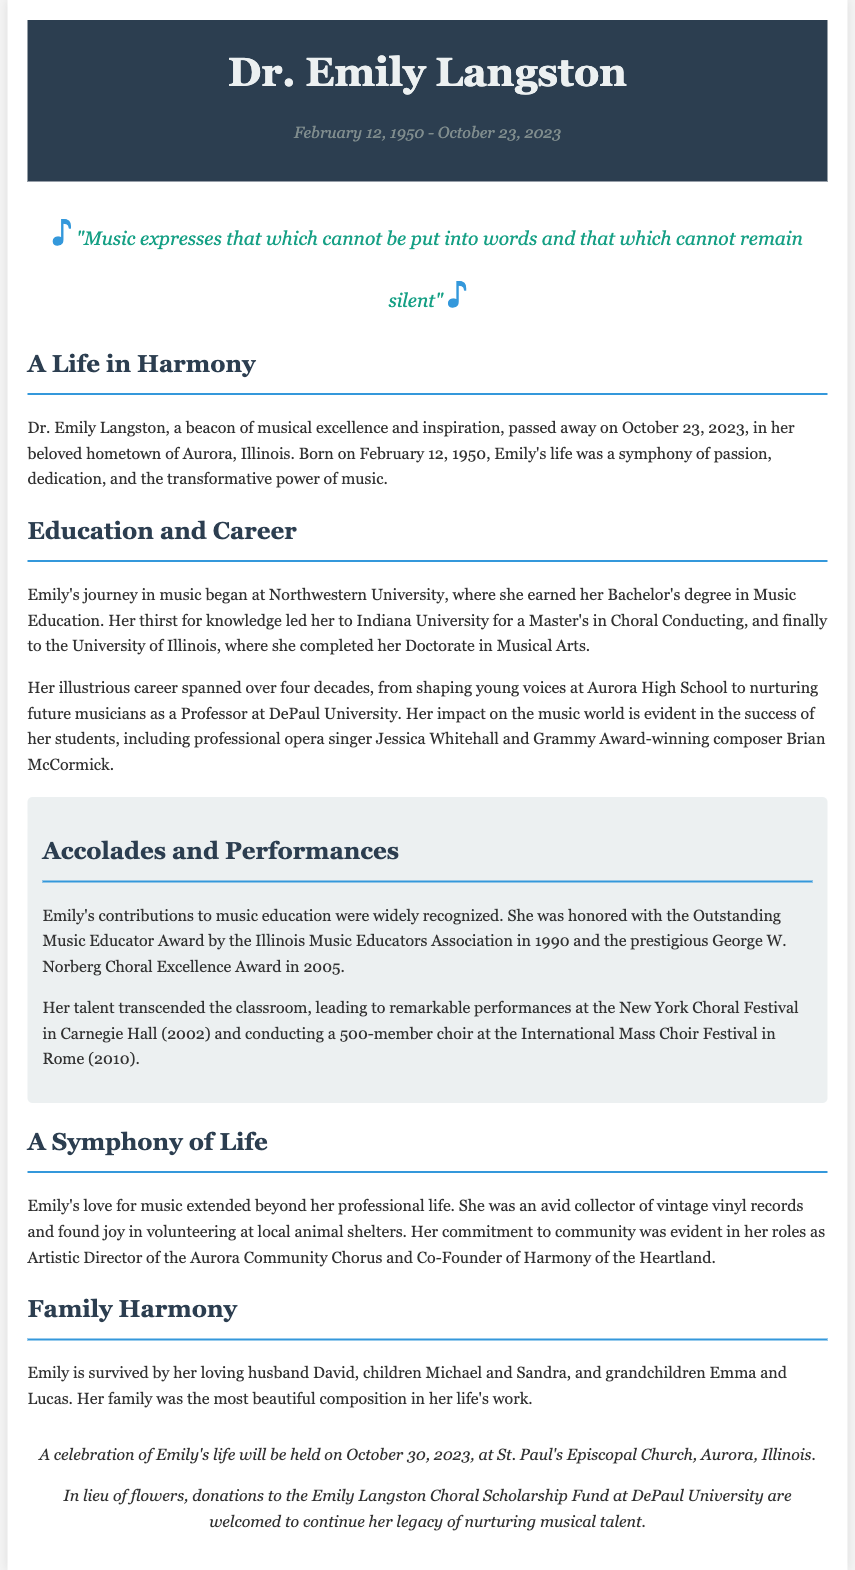What was Emily Langston's date of birth? The document states her birth date as February 12, 1950.
Answer: February 12, 1950 When did Emily Langston pass away? The document indicates that Emily passed away on October 23, 2023.
Answer: October 23, 2023 Where did Emily complete her Doctorate in Musical Arts? The document reveals that she completed her Doctorate at the University of Illinois.
Answer: University of Illinois Which award did Emily receive in 2005? The document mentions the George W. Norberg Choral Excellence Award was received in 2005.
Answer: George W. Norberg Choral Excellence Award What position did Emily hold at DePaul University? The document describes her role as a Professor at DePaul University.
Answer: Professor How many grandchildren does Emily Langston have? The document states that Emily has two grandchildren, Emma and Lucas.
Answer: Two What significant event is scheduled for October 30, 2023? The document notes that a celebration of Emily's life will be held on this date at St. Paul's Episcopal Church.
Answer: Celebration of life at St. Paul's Episcopal Church What was Emily's role in the Aurora Community Chorus? The document identifies her role as Artistic Director of the Aurora Community Chorus.
Answer: Artistic Director What is the name of the scholarship fund established in Emily's honor? The document specifies the Emily Langston Choral Scholarship Fund at DePaul University.
Answer: Emily Langston Choral Scholarship Fund 